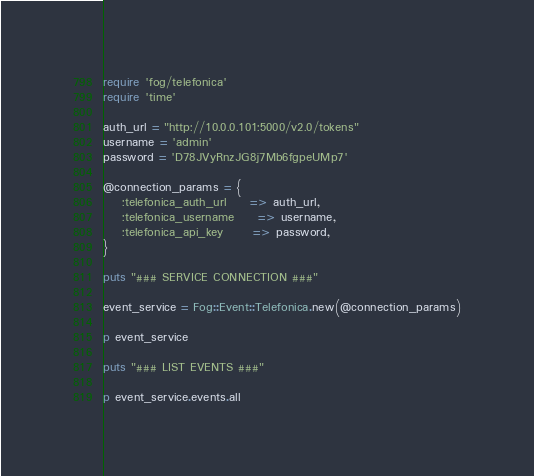<code> <loc_0><loc_0><loc_500><loc_500><_Ruby_>require 'fog/telefonica'
require 'time'

auth_url = "http://10.0.0.101:5000/v2.0/tokens"
username = 'admin'
password = 'D78JVyRnzJG8j7Mb6fgpeUMp7'

@connection_params = {
    :telefonica_auth_url     => auth_url,
    :telefonica_username     => username,
    :telefonica_api_key      => password,
}

puts "### SERVICE CONNECTION ###"

event_service = Fog::Event::Telefonica.new(@connection_params)

p event_service

puts "### LIST EVENTS ###"

p event_service.events.all
</code> 